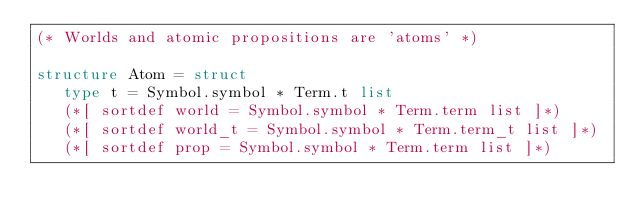Convert code to text. <code><loc_0><loc_0><loc_500><loc_500><_SML_>(* Worlds and atomic propositions are 'atoms' *)

structure Atom = struct
   type t = Symbol.symbol * Term.t list
   (*[ sortdef world = Symbol.symbol * Term.term list ]*)
   (*[ sortdef world_t = Symbol.symbol * Term.term_t list ]*)
   (*[ sortdef prop = Symbol.symbol * Term.term list ]*) </code> 